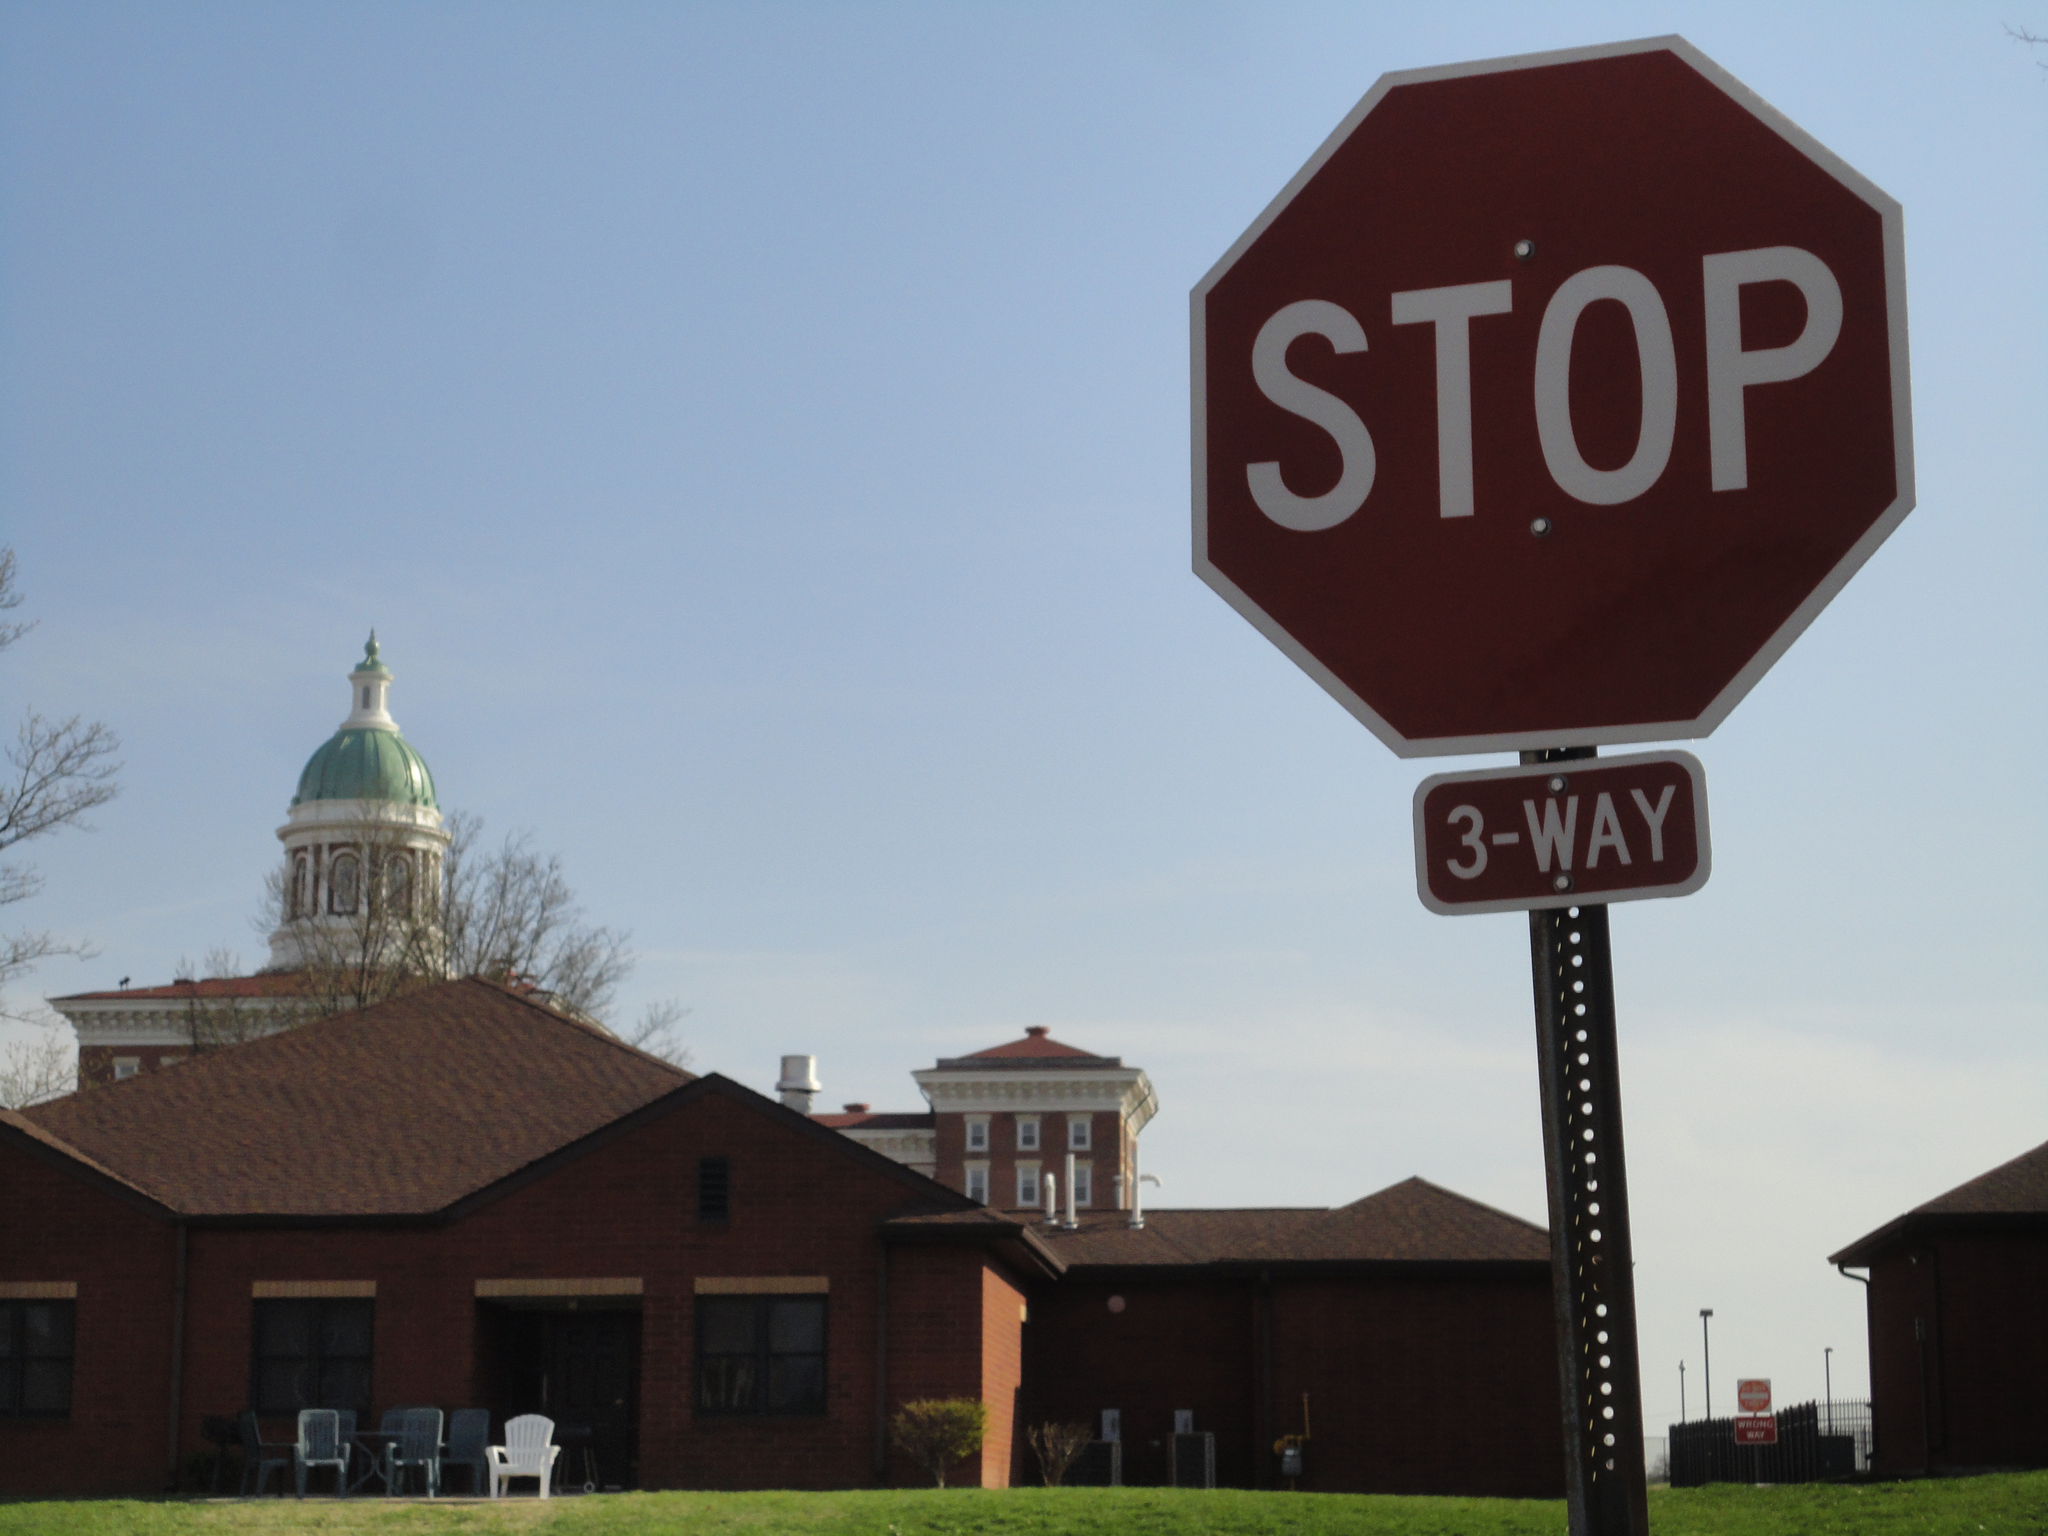Describe this image in one or two sentences. This picture is clicked outside. In the foreground we can see the green grass. On the right we can see the boards containing the text and number. In the center we can see the buildings, poles, plants, chairs and some objects. In the background we can see the sky, trees and a dome. 